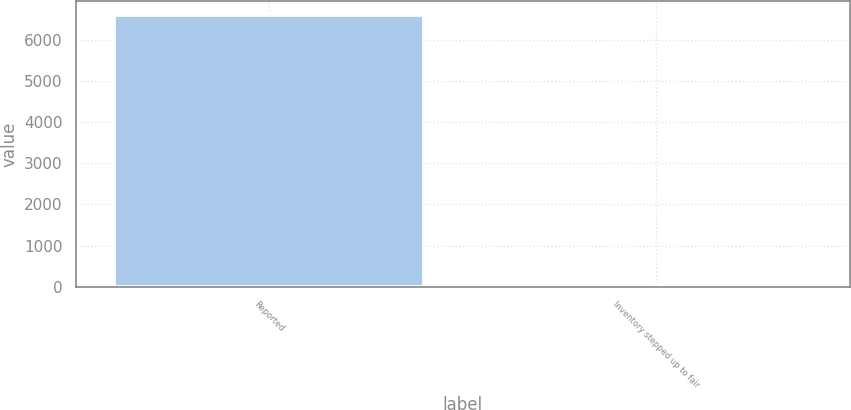<chart> <loc_0><loc_0><loc_500><loc_500><bar_chart><fcel>Reported<fcel>Inventory stepped up to fair<nl><fcel>6602<fcel>7<nl></chart> 